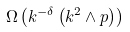Convert formula to latex. <formula><loc_0><loc_0><loc_500><loc_500>\Omega \left ( k ^ { - \delta } \left ( k ^ { 2 } \wedge p \right ) \right )</formula> 